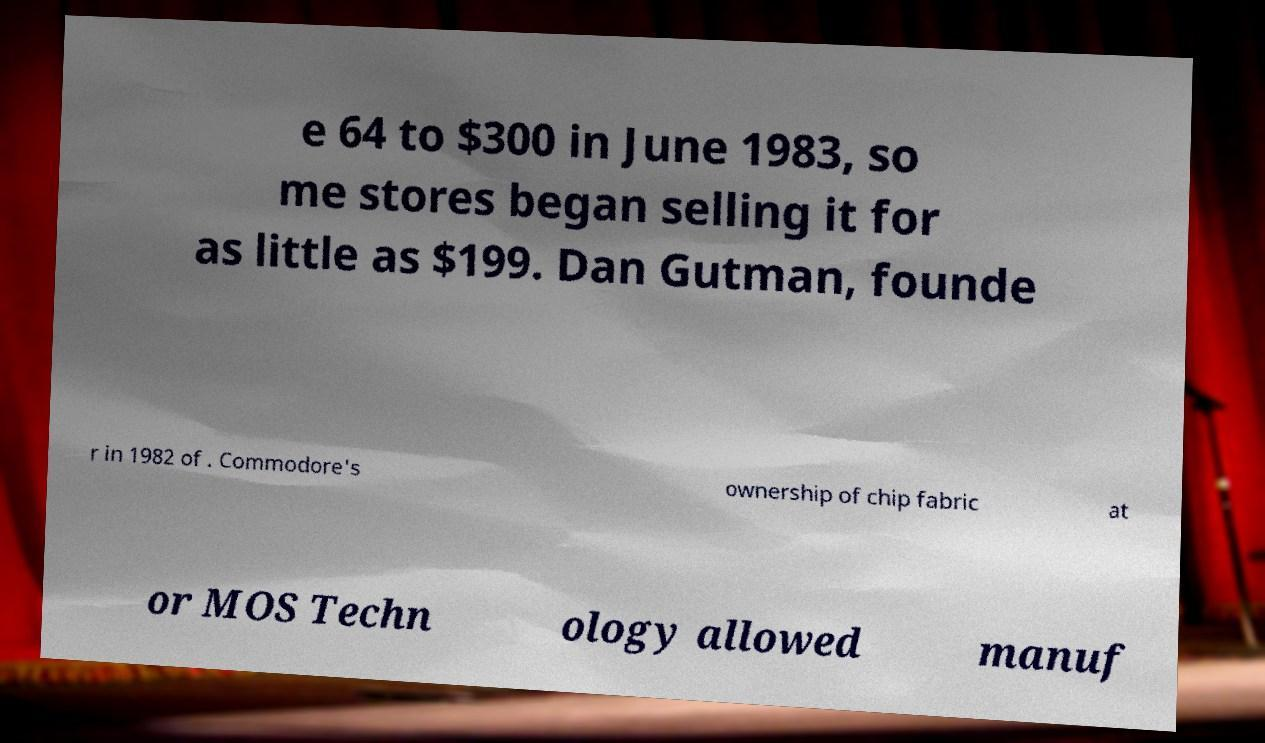Could you extract and type out the text from this image? e 64 to $300 in June 1983, so me stores began selling it for as little as $199. Dan Gutman, founde r in 1982 of . Commodore's ownership of chip fabric at or MOS Techn ology allowed manuf 